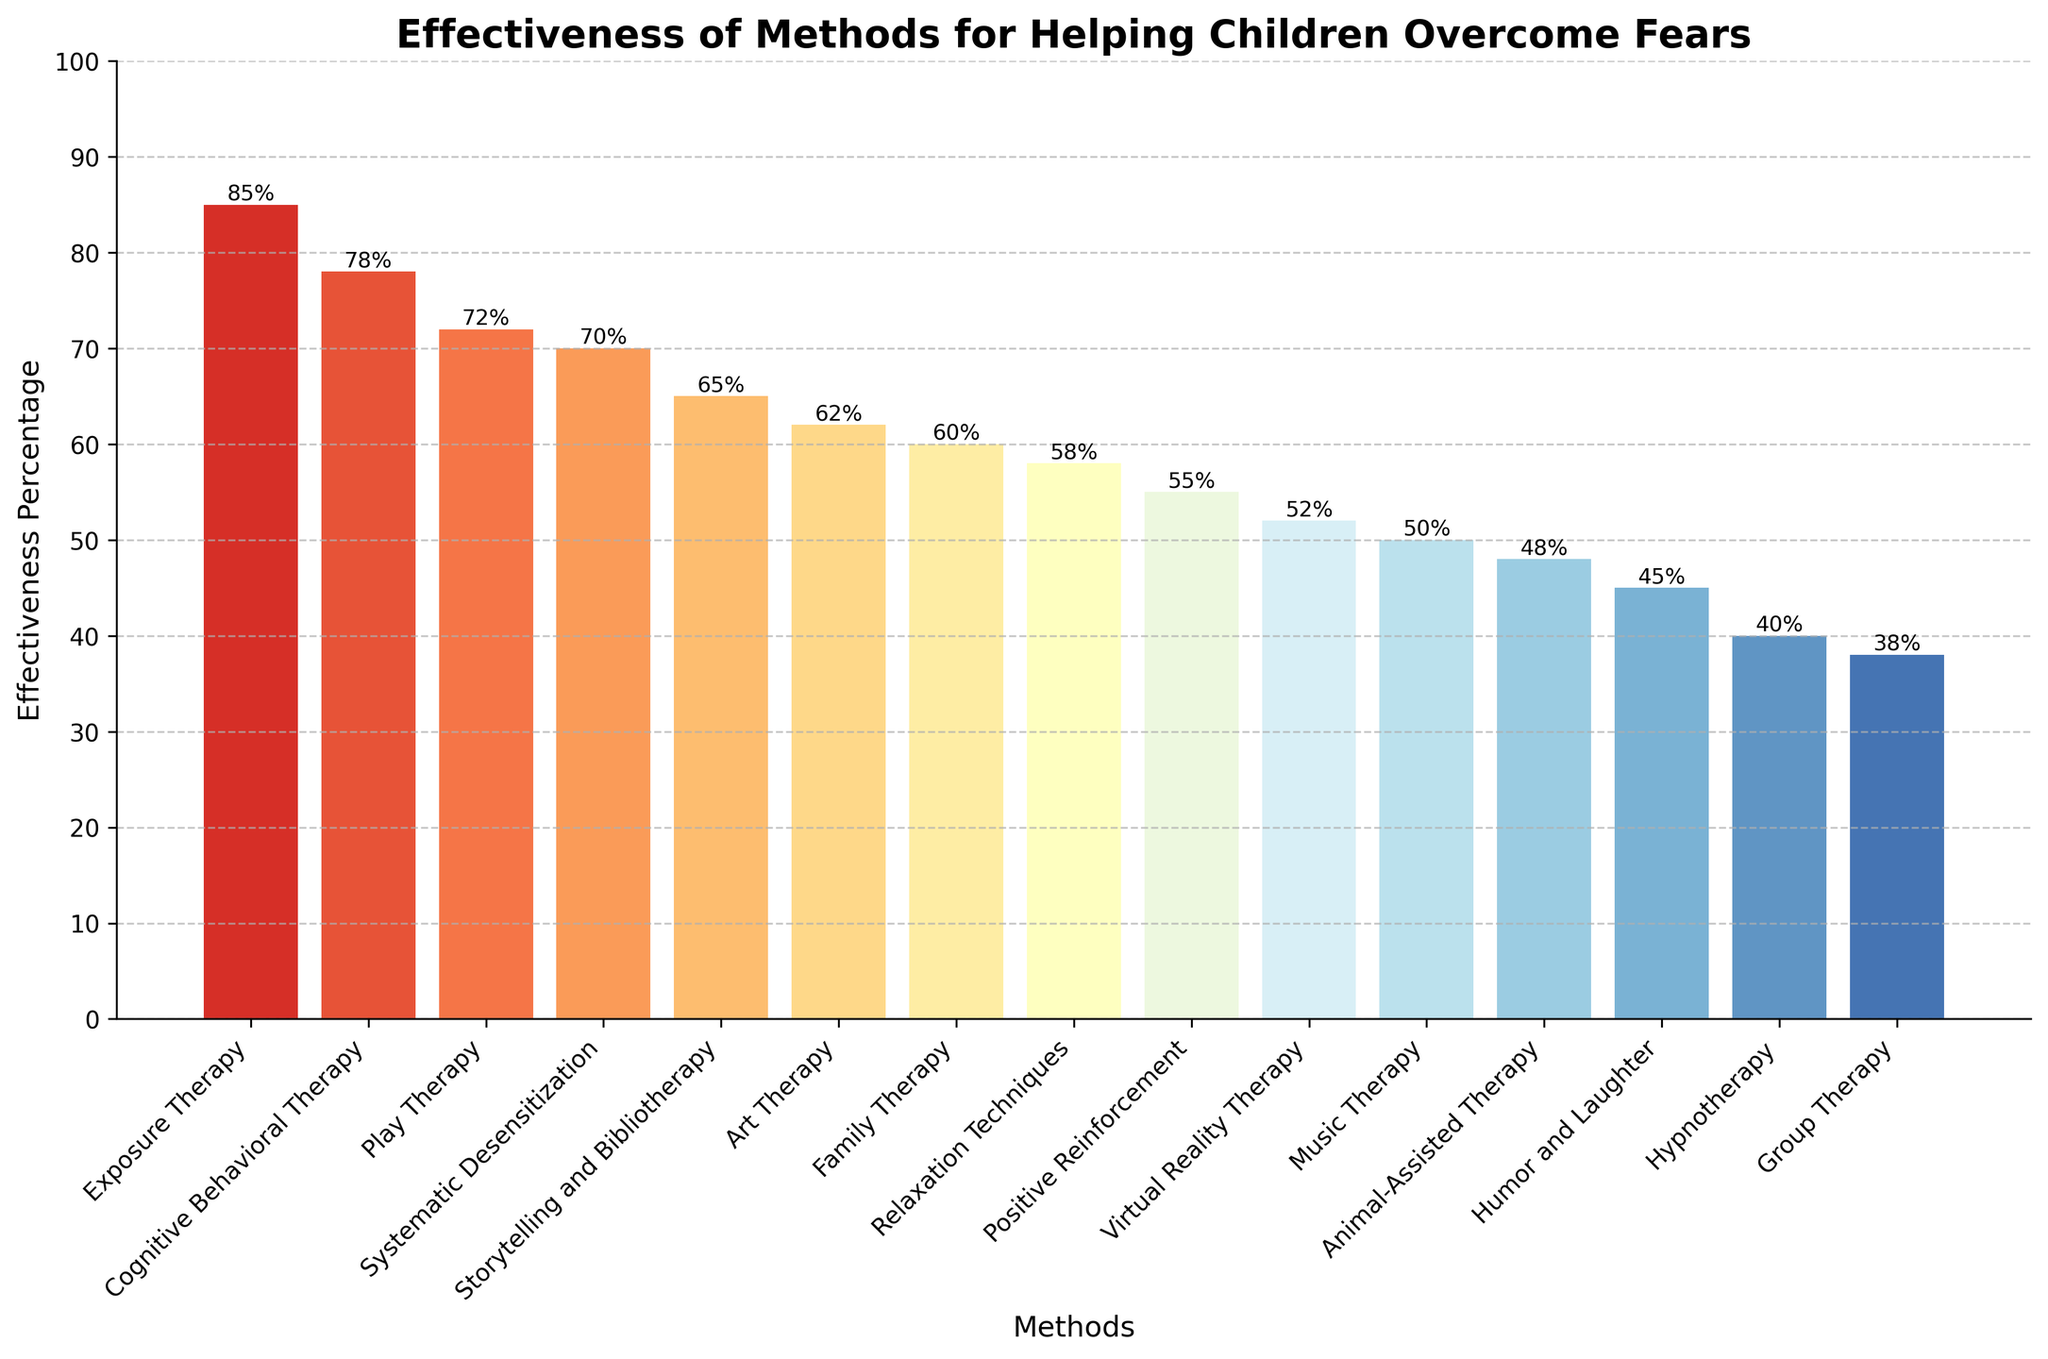What method is the most effective according to the chart? Look for the tallest bar in the chart. The tallest bar represents "Exposure Therapy" with an effectiveness percentage of 85%.
Answer: Exposure Therapy What is the combined effectiveness percentage of the three least effective methods? Identify the three shortest bars (Group Therapy, Hypnotherapy, and Humor and Laughter) and sum their effectiveness percentages: 38% + 40% + 45% = 123%.
Answer: 123% Which method has a higher effectiveness percentage, Play Therapy or Systematic Desensitization? Compare the heights of the bars for Play Therapy (72%) and Systematic Desensitization (70%). 72% is greater than 70%.
Answer: Play Therapy What is the difference in effectiveness between Cognitive Behavioral Therapy and Virtual Reality Therapy? Find the effectiveness percentages of both methods: Cognitive Behavioral Therapy (78%) and Virtual Reality Therapy (52%). Subtract the smaller value from the larger: 78% - 52% = 26%.
Answer: 26% Which method has an effectiveness percentage closest to 50%? Locate the bar closest to the halfway point between 0% and 100%. Music Therapy is at 50%.
Answer: Music Therapy What's the total effectiveness percentage of all methods that use the word "Therapy" in their name? Sum the effectiveness percentages of all methods with "Therapy" in their names: Exposure Therapy (85%), Cognitive Behavioral Therapy (78%), Play Therapy (72%), Art Therapy (62%), Family Therapy (60%), and Virtual Reality Therapy (52%), Music Therapy (50%), Hypnotherapy (40%), Group Therapy (38%): 85% + 78% + 72% + 62% + 60% + 52% + 50% + 40% + 38% = 537%.
Answer: 537% Are there more methods with effectiveness percentages above or below 60%? Count the bars above and below 60%:
Above 60%: Exposure Therapy, Cognitive Behavioral Therapy, Play Therapy, Systematic Desensitization, Storytelling and Bibliotherapy, Art Therapy.
Below 60%: Family Therapy, Relaxation Techniques, Positive Reinforcement, Virtual Reality Therapy, Music Therapy, Animal-Assisted Therapy, Humor and Laughter, Hypnotherapy, Group Therapy.
6 methods are above, and 9 are below.
Answer: Below 60% Which methods have an effectiveness percentage higher than 70%? Identify the bars with a height above 70%: Exposure Therapy (85%), Cognitive Behavioral Therapy (78%), Play Therapy (72%).
Answer: Exposure Therapy, Cognitive Behavioral Therapy, Play Therapy What is the average effectiveness percentage of the top 5 methods? Identify the top 5 methods by height: Exposure Therapy (85%), Cognitive Behavioral Therapy (78%), Play Therapy (72%), Systematic Desensitization (70%), Storytelling and Bibliotherapy (65%). Sum these percentages: 85% + 78% + 72% + 70% + 65% = 370%. Divide by 5: 370% / 5 = 74%.
Answer: 74% Between Art Therapy and Animal-Assisted Therapy, which has a lower effectiveness percentage? Compare the heights of the bars for Art Therapy (62%) and Animal-Assisted Therapy (48%). 48% is less than 62%.
Answer: Animal-Assisted Therapy 